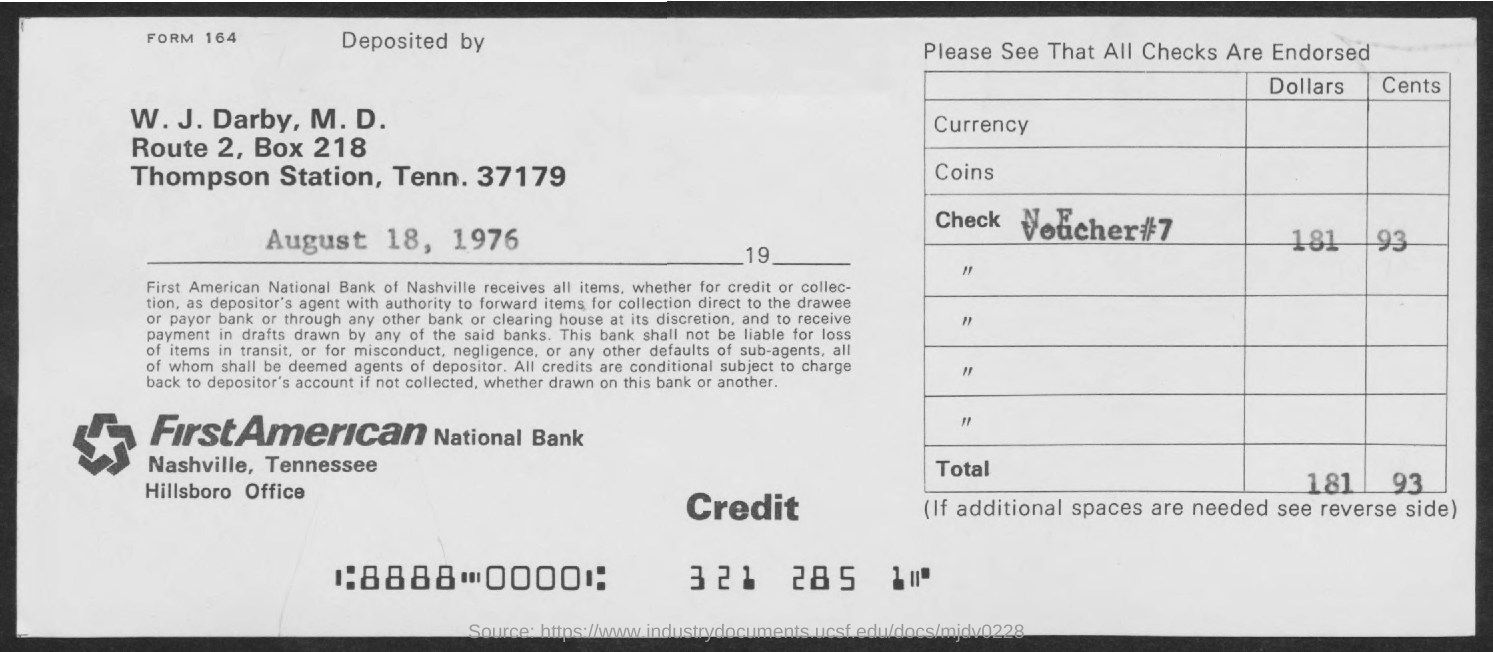Indicate a few pertinent items in this graphic. The voucher number is 7. The Box Number is 218. The name of the bank is FirstAmerican National Bank. 